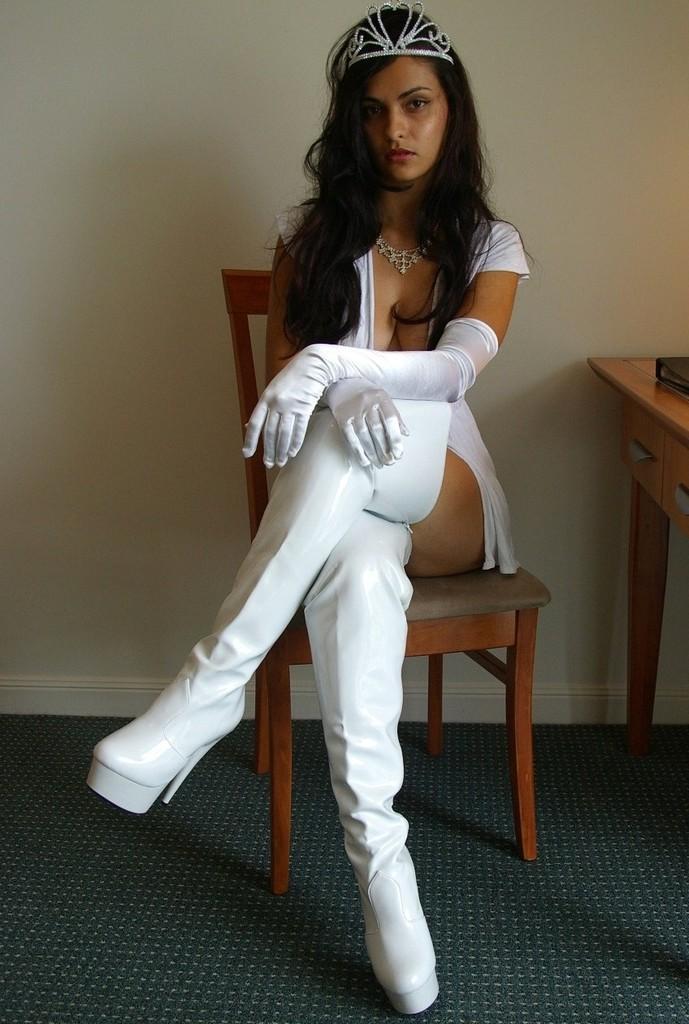How would you summarize this image in a sentence or two? In this picture I can see a woman sitting on the chair and side there is a table placed. 